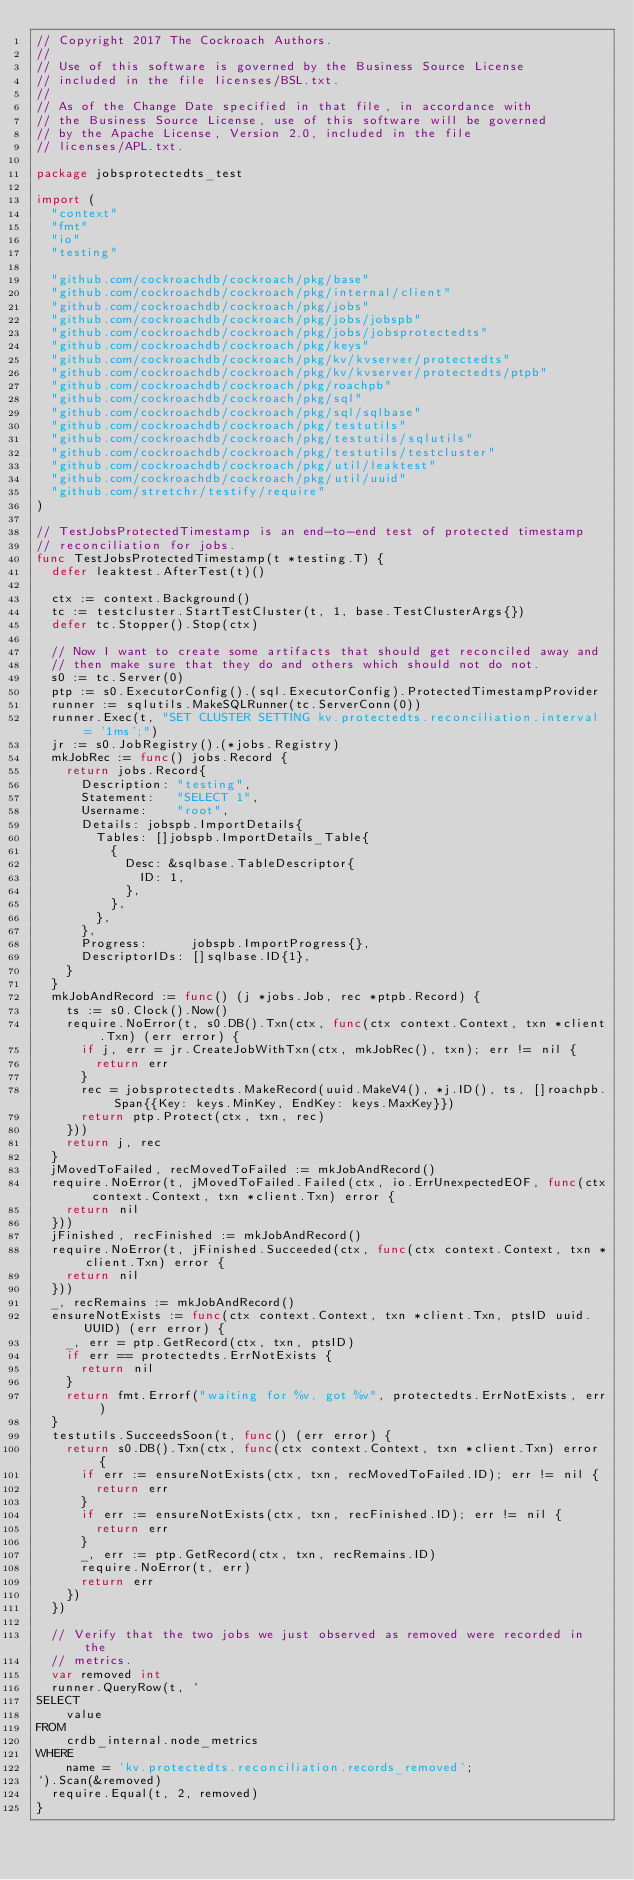Convert code to text. <code><loc_0><loc_0><loc_500><loc_500><_Go_>// Copyright 2017 The Cockroach Authors.
//
// Use of this software is governed by the Business Source License
// included in the file licenses/BSL.txt.
//
// As of the Change Date specified in that file, in accordance with
// the Business Source License, use of this software will be governed
// by the Apache License, Version 2.0, included in the file
// licenses/APL.txt.

package jobsprotectedts_test

import (
	"context"
	"fmt"
	"io"
	"testing"

	"github.com/cockroachdb/cockroach/pkg/base"
	"github.com/cockroachdb/cockroach/pkg/internal/client"
	"github.com/cockroachdb/cockroach/pkg/jobs"
	"github.com/cockroachdb/cockroach/pkg/jobs/jobspb"
	"github.com/cockroachdb/cockroach/pkg/jobs/jobsprotectedts"
	"github.com/cockroachdb/cockroach/pkg/keys"
	"github.com/cockroachdb/cockroach/pkg/kv/kvserver/protectedts"
	"github.com/cockroachdb/cockroach/pkg/kv/kvserver/protectedts/ptpb"
	"github.com/cockroachdb/cockroach/pkg/roachpb"
	"github.com/cockroachdb/cockroach/pkg/sql"
	"github.com/cockroachdb/cockroach/pkg/sql/sqlbase"
	"github.com/cockroachdb/cockroach/pkg/testutils"
	"github.com/cockroachdb/cockroach/pkg/testutils/sqlutils"
	"github.com/cockroachdb/cockroach/pkg/testutils/testcluster"
	"github.com/cockroachdb/cockroach/pkg/util/leaktest"
	"github.com/cockroachdb/cockroach/pkg/util/uuid"
	"github.com/stretchr/testify/require"
)

// TestJobsProtectedTimestamp is an end-to-end test of protected timestamp
// reconciliation for jobs.
func TestJobsProtectedTimestamp(t *testing.T) {
	defer leaktest.AfterTest(t)()

	ctx := context.Background()
	tc := testcluster.StartTestCluster(t, 1, base.TestClusterArgs{})
	defer tc.Stopper().Stop(ctx)

	// Now I want to create some artifacts that should get reconciled away and
	// then make sure that they do and others which should not do not.
	s0 := tc.Server(0)
	ptp := s0.ExecutorConfig().(sql.ExecutorConfig).ProtectedTimestampProvider
	runner := sqlutils.MakeSQLRunner(tc.ServerConn(0))
	runner.Exec(t, "SET CLUSTER SETTING kv.protectedts.reconciliation.interval = '1ms';")
	jr := s0.JobRegistry().(*jobs.Registry)
	mkJobRec := func() jobs.Record {
		return jobs.Record{
			Description: "testing",
			Statement:   "SELECT 1",
			Username:    "root",
			Details: jobspb.ImportDetails{
				Tables: []jobspb.ImportDetails_Table{
					{
						Desc: &sqlbase.TableDescriptor{
							ID: 1,
						},
					},
				},
			},
			Progress:      jobspb.ImportProgress{},
			DescriptorIDs: []sqlbase.ID{1},
		}
	}
	mkJobAndRecord := func() (j *jobs.Job, rec *ptpb.Record) {
		ts := s0.Clock().Now()
		require.NoError(t, s0.DB().Txn(ctx, func(ctx context.Context, txn *client.Txn) (err error) {
			if j, err = jr.CreateJobWithTxn(ctx, mkJobRec(), txn); err != nil {
				return err
			}
			rec = jobsprotectedts.MakeRecord(uuid.MakeV4(), *j.ID(), ts, []roachpb.Span{{Key: keys.MinKey, EndKey: keys.MaxKey}})
			return ptp.Protect(ctx, txn, rec)
		}))
		return j, rec
	}
	jMovedToFailed, recMovedToFailed := mkJobAndRecord()
	require.NoError(t, jMovedToFailed.Failed(ctx, io.ErrUnexpectedEOF, func(ctx context.Context, txn *client.Txn) error {
		return nil
	}))
	jFinished, recFinished := mkJobAndRecord()
	require.NoError(t, jFinished.Succeeded(ctx, func(ctx context.Context, txn *client.Txn) error {
		return nil
	}))
	_, recRemains := mkJobAndRecord()
	ensureNotExists := func(ctx context.Context, txn *client.Txn, ptsID uuid.UUID) (err error) {
		_, err = ptp.GetRecord(ctx, txn, ptsID)
		if err == protectedts.ErrNotExists {
			return nil
		}
		return fmt.Errorf("waiting for %v, got %v", protectedts.ErrNotExists, err)
	}
	testutils.SucceedsSoon(t, func() (err error) {
		return s0.DB().Txn(ctx, func(ctx context.Context, txn *client.Txn) error {
			if err := ensureNotExists(ctx, txn, recMovedToFailed.ID); err != nil {
				return err
			}
			if err := ensureNotExists(ctx, txn, recFinished.ID); err != nil {
				return err
			}
			_, err := ptp.GetRecord(ctx, txn, recRemains.ID)
			require.NoError(t, err)
			return err
		})
	})

	// Verify that the two jobs we just observed as removed were recorded in the
	// metrics.
	var removed int
	runner.QueryRow(t, `
SELECT
    value
FROM
    crdb_internal.node_metrics
WHERE
    name = 'kv.protectedts.reconciliation.records_removed';
`).Scan(&removed)
	require.Equal(t, 2, removed)
}
</code> 